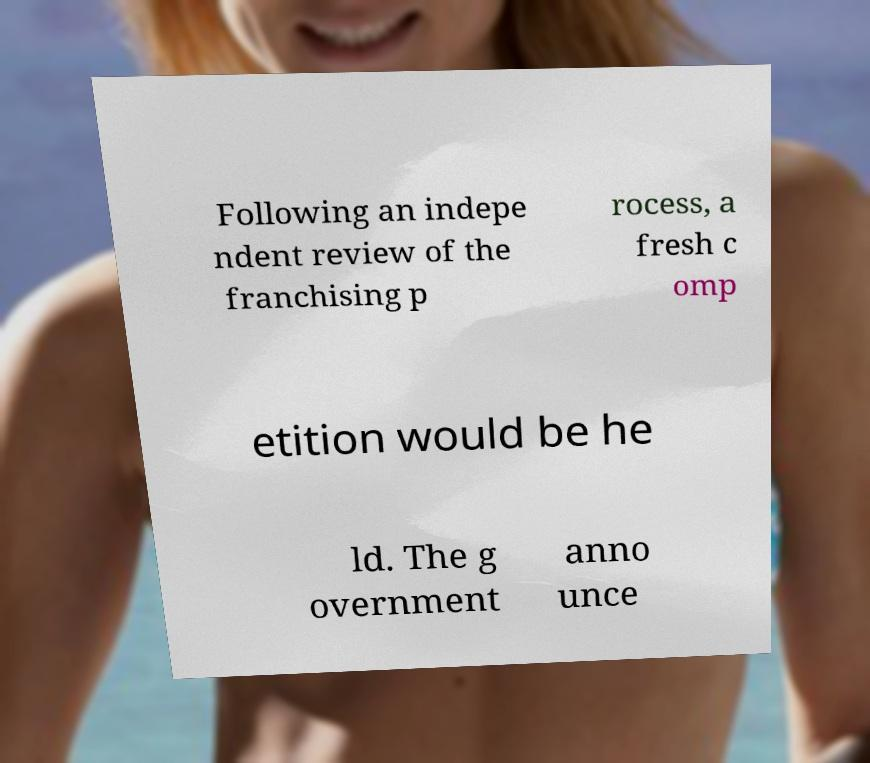Please identify and transcribe the text found in this image. Following an indepe ndent review of the franchising p rocess, a fresh c omp etition would be he ld. The g overnment anno unce 